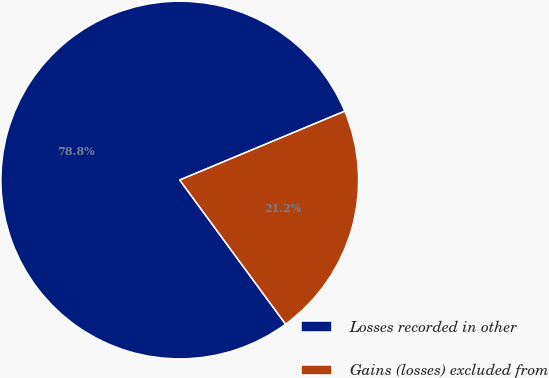Convert chart. <chart><loc_0><loc_0><loc_500><loc_500><pie_chart><fcel>Losses recorded in other<fcel>Gains (losses) excluded from<nl><fcel>78.79%<fcel>21.21%<nl></chart> 